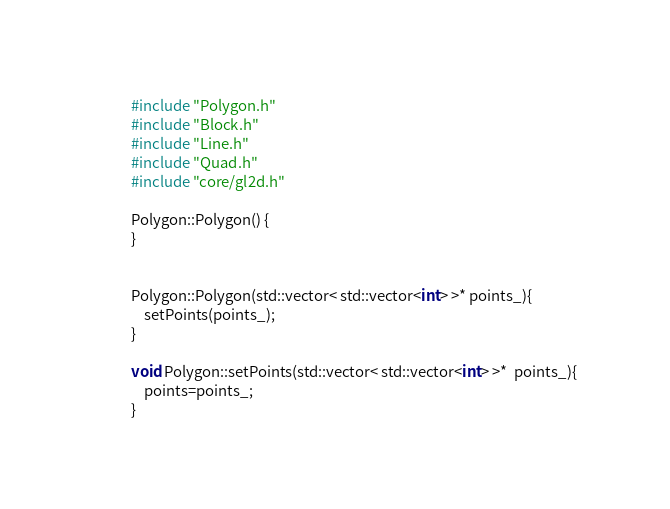Convert code to text. <code><loc_0><loc_0><loc_500><loc_500><_C++_>#include "Polygon.h"
#include "Block.h"
#include "Line.h"
#include "Quad.h"
#include "core/gl2d.h"

Polygon::Polygon() {
}


Polygon::Polygon(std::vector< std::vector<int> >* points_){
	setPoints(points_);
}

void Polygon::setPoints(std::vector< std::vector<int> >*  points_){
	points=points_;
}
</code> 